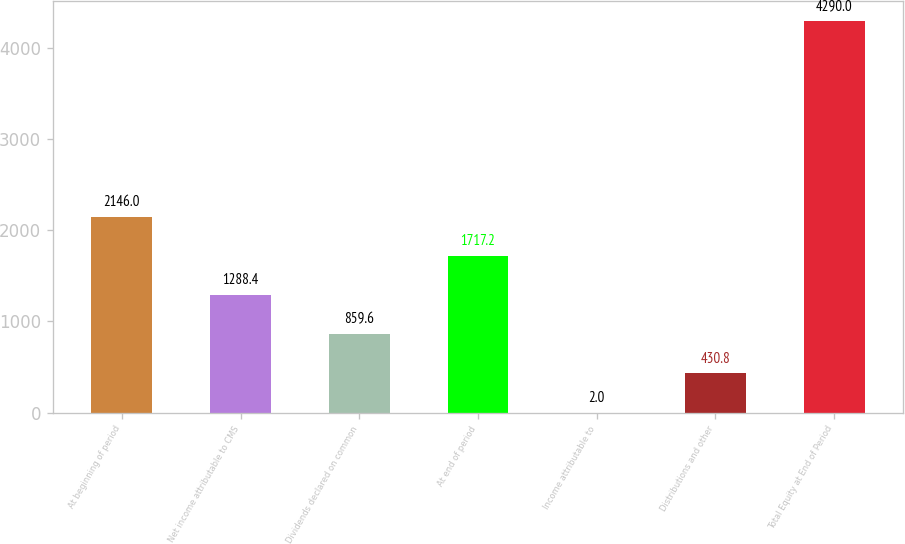<chart> <loc_0><loc_0><loc_500><loc_500><bar_chart><fcel>At beginning of period<fcel>Net income attributable to CMS<fcel>Dividends declared on common<fcel>At end of period<fcel>Income attributable to<fcel>Distributions and other<fcel>Total Equity at End of Period<nl><fcel>2146<fcel>1288.4<fcel>859.6<fcel>1717.2<fcel>2<fcel>430.8<fcel>4290<nl></chart> 